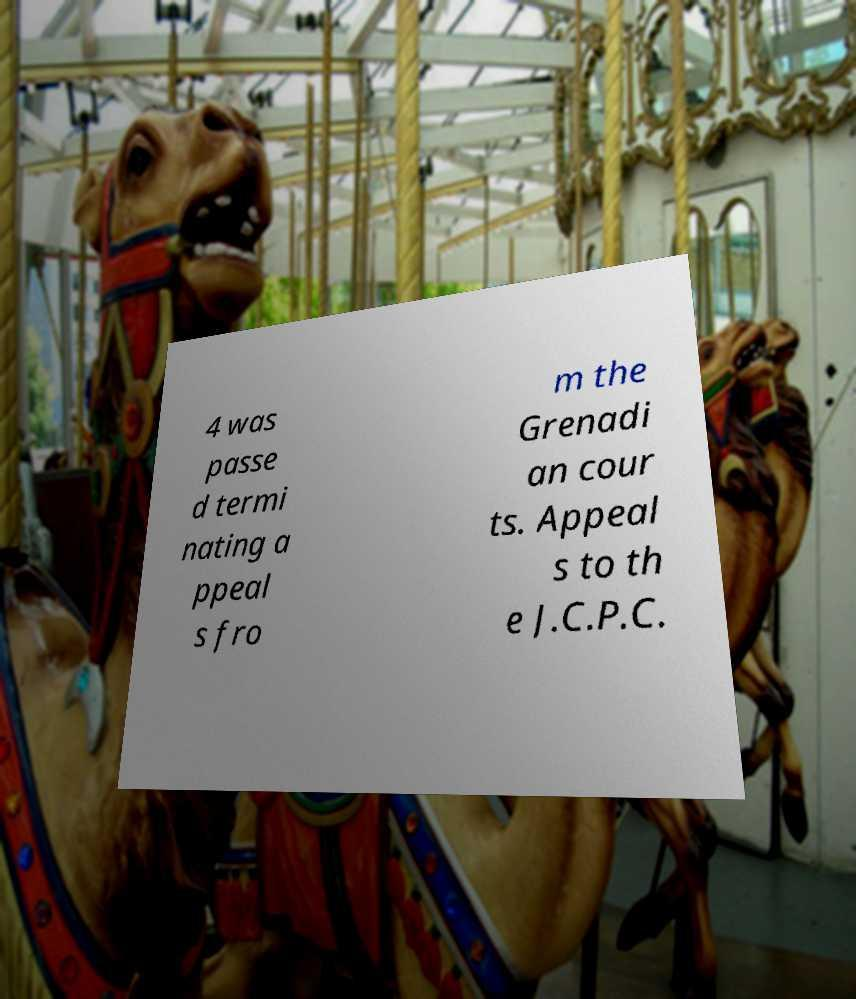Please read and relay the text visible in this image. What does it say? 4 was passe d termi nating a ppeal s fro m the Grenadi an cour ts. Appeal s to th e J.C.P.C. 